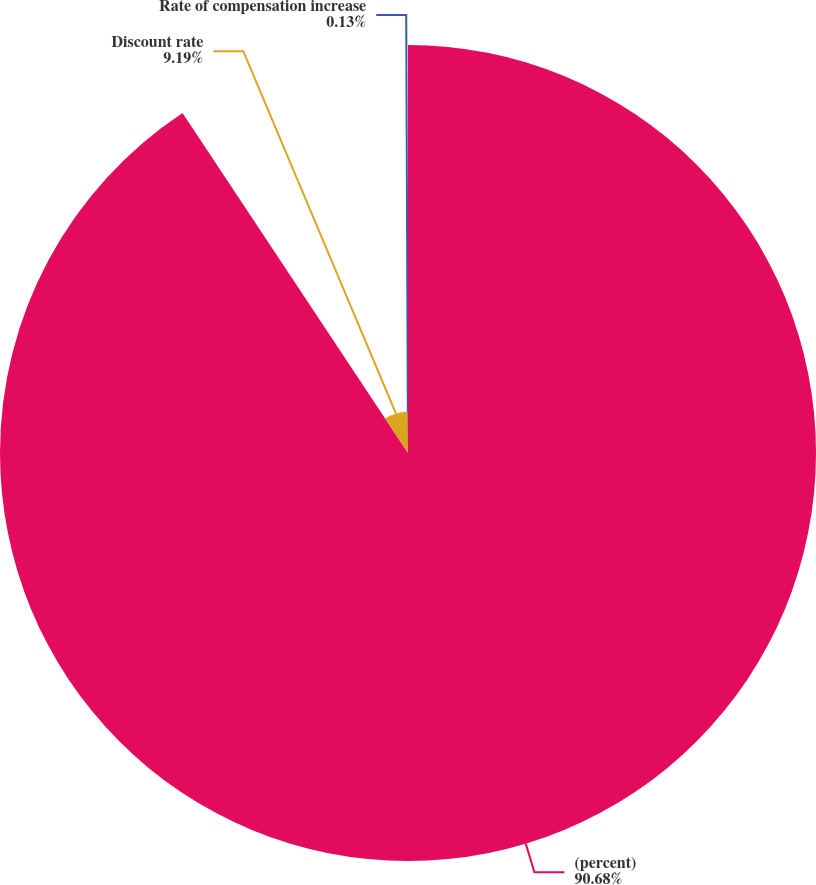<chart> <loc_0><loc_0><loc_500><loc_500><pie_chart><fcel>(percent)<fcel>Discount rate<fcel>Rate of compensation increase<nl><fcel>90.68%<fcel>9.19%<fcel>0.13%<nl></chart> 